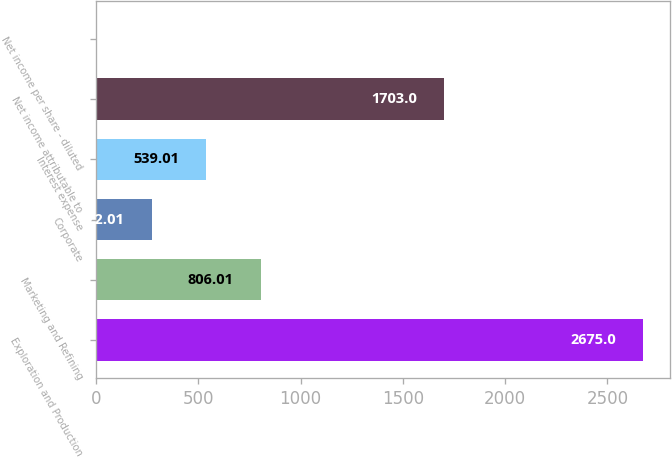Convert chart to OTSL. <chart><loc_0><loc_0><loc_500><loc_500><bar_chart><fcel>Exploration and Production<fcel>Marketing and Refining<fcel>Corporate<fcel>Interest expense<fcel>Net income attributable to<fcel>Net income per share - diluted<nl><fcel>2675<fcel>806.01<fcel>272.01<fcel>539.01<fcel>1703<fcel>5.01<nl></chart> 